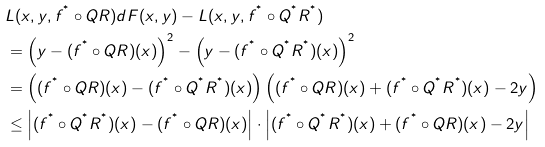<formula> <loc_0><loc_0><loc_500><loc_500>& L ( x , y , f ^ { ^ { * } } \circ Q R ) d F ( x , y ) - L ( x , y , f ^ { ^ { * } } \circ Q ^ { ^ { * } } R ^ { ^ { * } } ) \\ & = \left ( y - ( f ^ { ^ { * } } \circ Q R ) ( x ) \right ) ^ { 2 } - \left ( y - ( f ^ { ^ { * } } \circ Q ^ { ^ { * } } R ^ { ^ { * } } ) ( x ) \right ) ^ { 2 } \\ & = \left ( ( f ^ { ^ { * } } \circ Q R ) ( x ) - ( f ^ { ^ { * } } \circ Q ^ { ^ { * } } R ^ { ^ { * } } ) ( x ) \right ) \left ( ( f ^ { ^ { * } } \circ Q R ) ( x ) + ( f ^ { ^ { * } } \circ Q ^ { ^ { * } } R ^ { ^ { * } } ) ( x ) - 2 y \right ) \\ & \leq \left | ( f ^ { ^ { * } } \circ Q ^ { ^ { * } } R ^ { ^ { * } } ) ( x ) - ( f ^ { ^ { * } } \circ Q R ) ( x ) \right | \cdot \left | ( f ^ { ^ { * } } \circ Q ^ { ^ { * } } R ^ { ^ { * } } ) ( x ) + ( f ^ { ^ { * } } \circ Q R ) ( x ) - 2 y \right |</formula> 